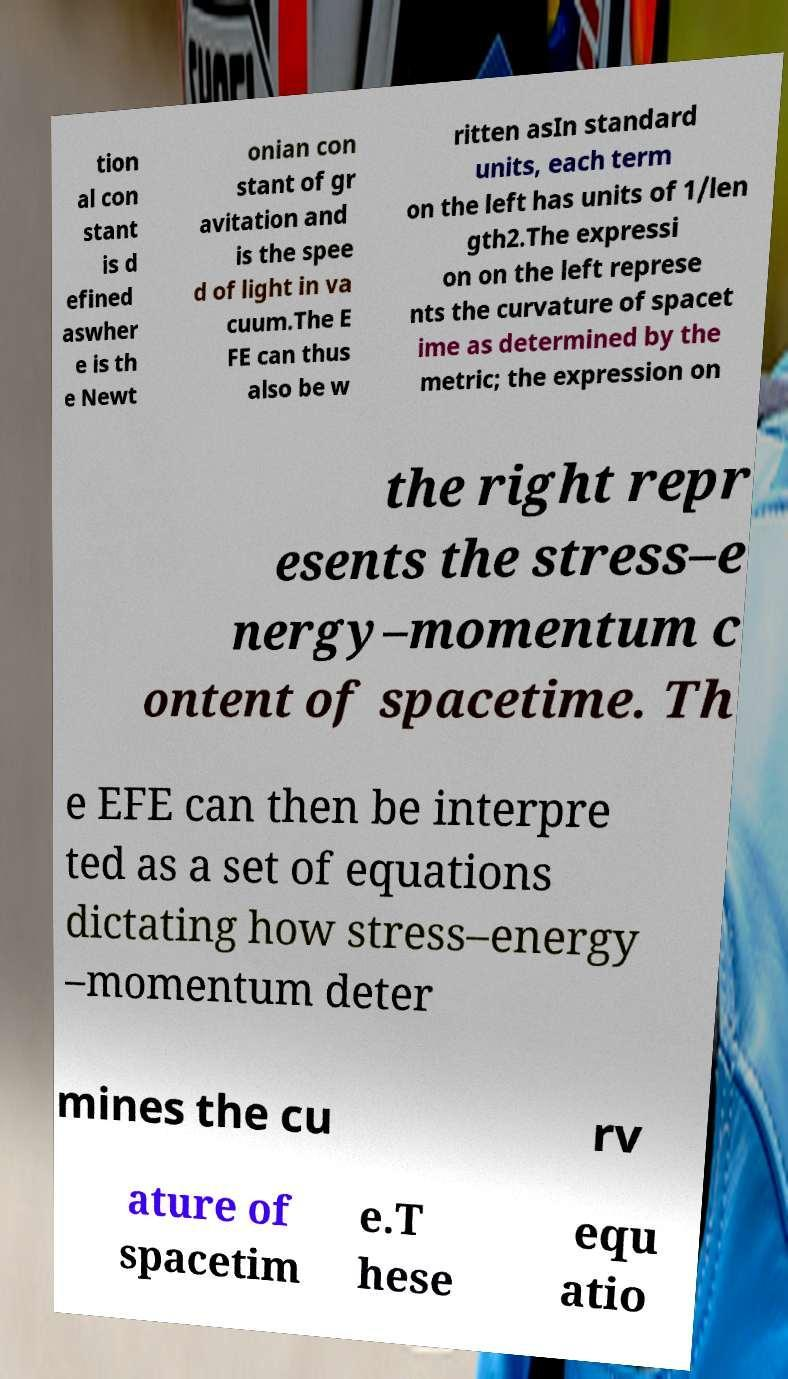Please identify and transcribe the text found in this image. tion al con stant is d efined aswher e is th e Newt onian con stant of gr avitation and is the spee d of light in va cuum.The E FE can thus also be w ritten asIn standard units, each term on the left has units of 1/len gth2.The expressi on on the left represe nts the curvature of spacet ime as determined by the metric; the expression on the right repr esents the stress–e nergy–momentum c ontent of spacetime. Th e EFE can then be interpre ted as a set of equations dictating how stress–energy –momentum deter mines the cu rv ature of spacetim e.T hese equ atio 